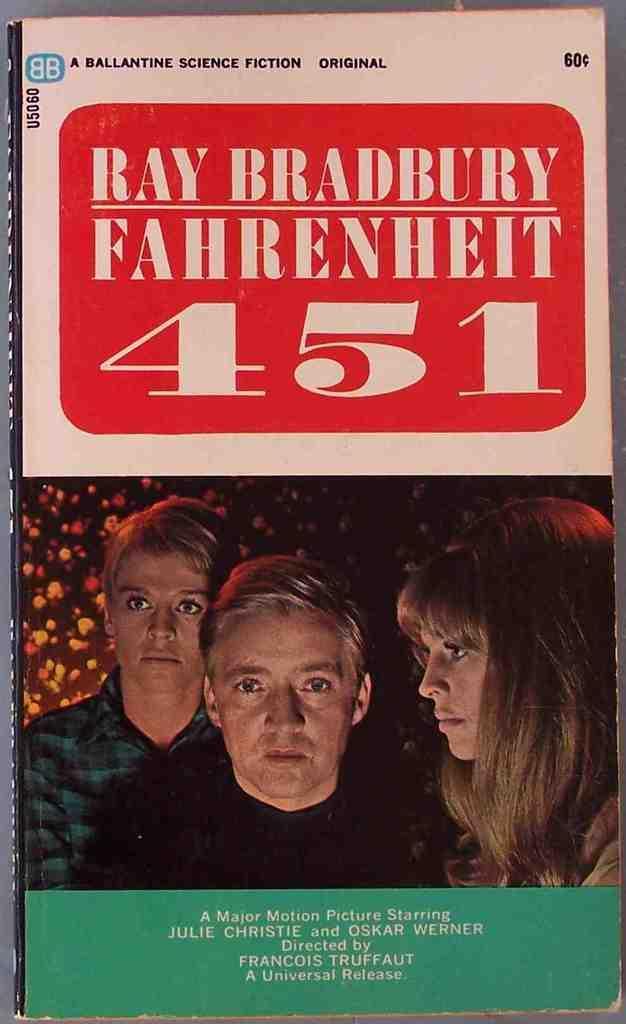Can you describe this image briefly? In the center of the image there is a book. There are persons on the front page of the book and there is some text. 